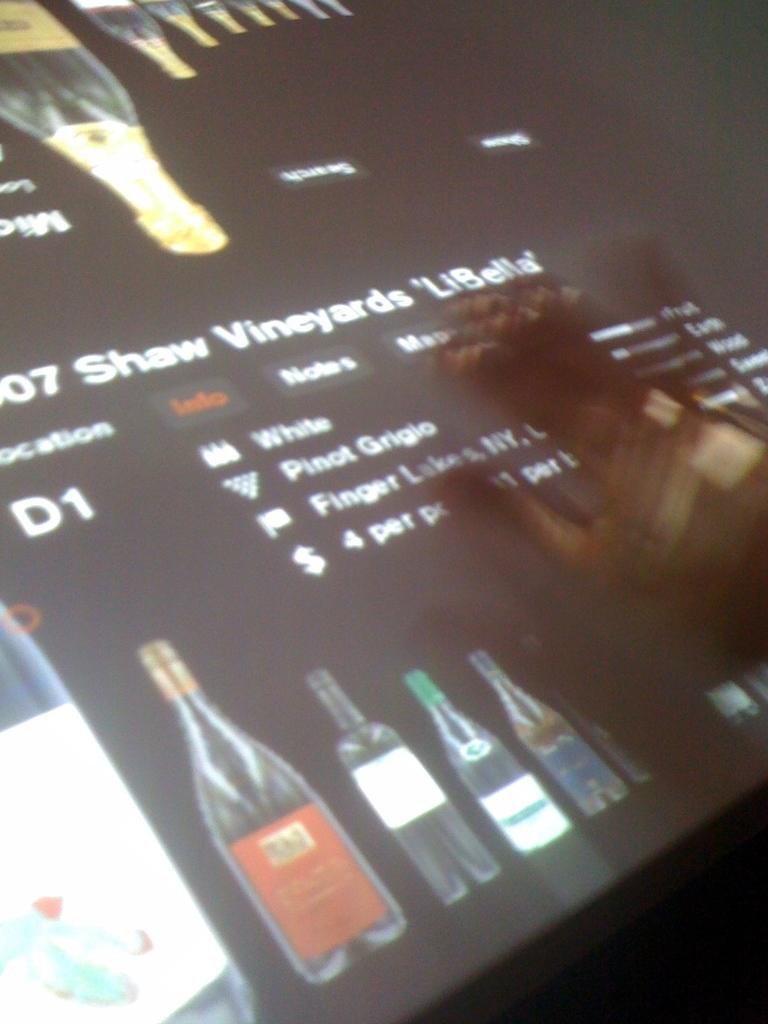What is the main object in the image? There is a screen in the image. What is displayed on the screen? Pictures of bottles are visible on the screen, along with text. Can you describe the hand in the image? There is a person's hand on the right side of the image. What type of protest is taking place in the image? There is no protest present in the image; it features a screen with pictures of bottles and text. What kind of lamp is illuminating the screen in the image? There is no lamp present in the image; the screen is the main focus. 